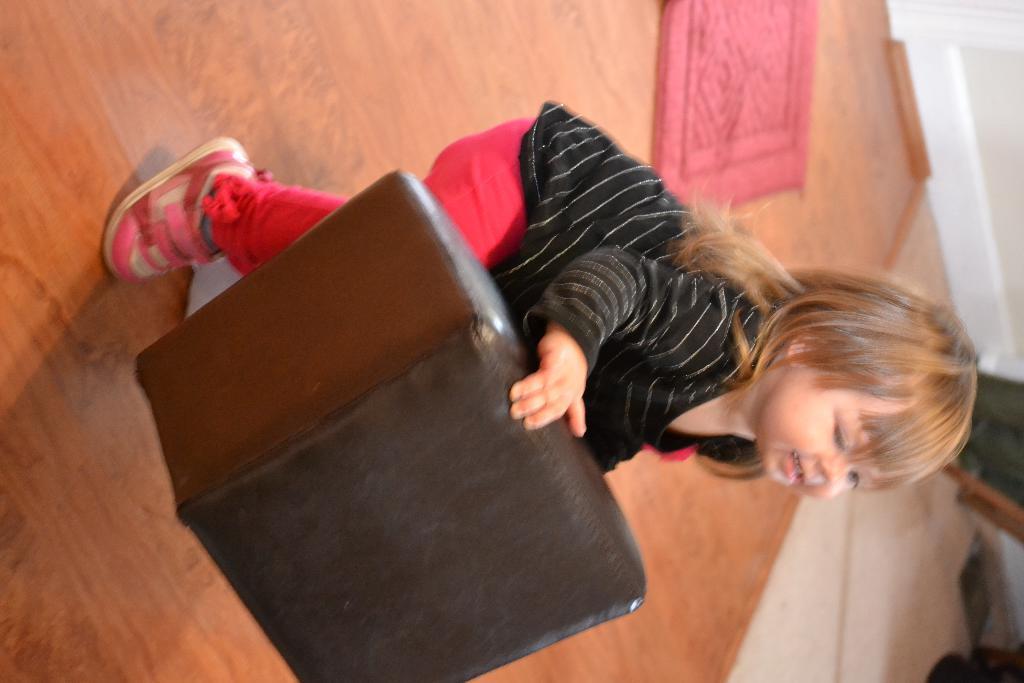Could you give a brief overview of what you see in this image? In this image we can see a girl and she is holding an object in her hand. There is an object at the right side of the image. There is a mat on the floor in the image. 